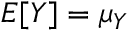Convert formula to latex. <formula><loc_0><loc_0><loc_500><loc_500>E [ Y ] = \mu _ { Y }</formula> 